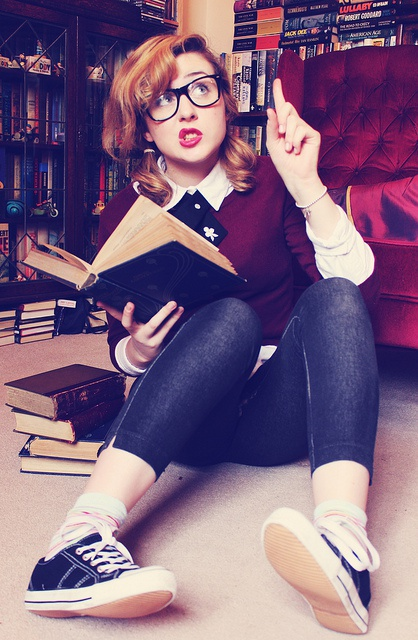Describe the objects in this image and their specific colors. I can see people in navy, ivory, purple, and lightpink tones, book in navy, purple, brown, and tan tones, couch in navy, purple, and brown tones, chair in navy, purple, and brown tones, and book in navy, tan, and brown tones in this image. 